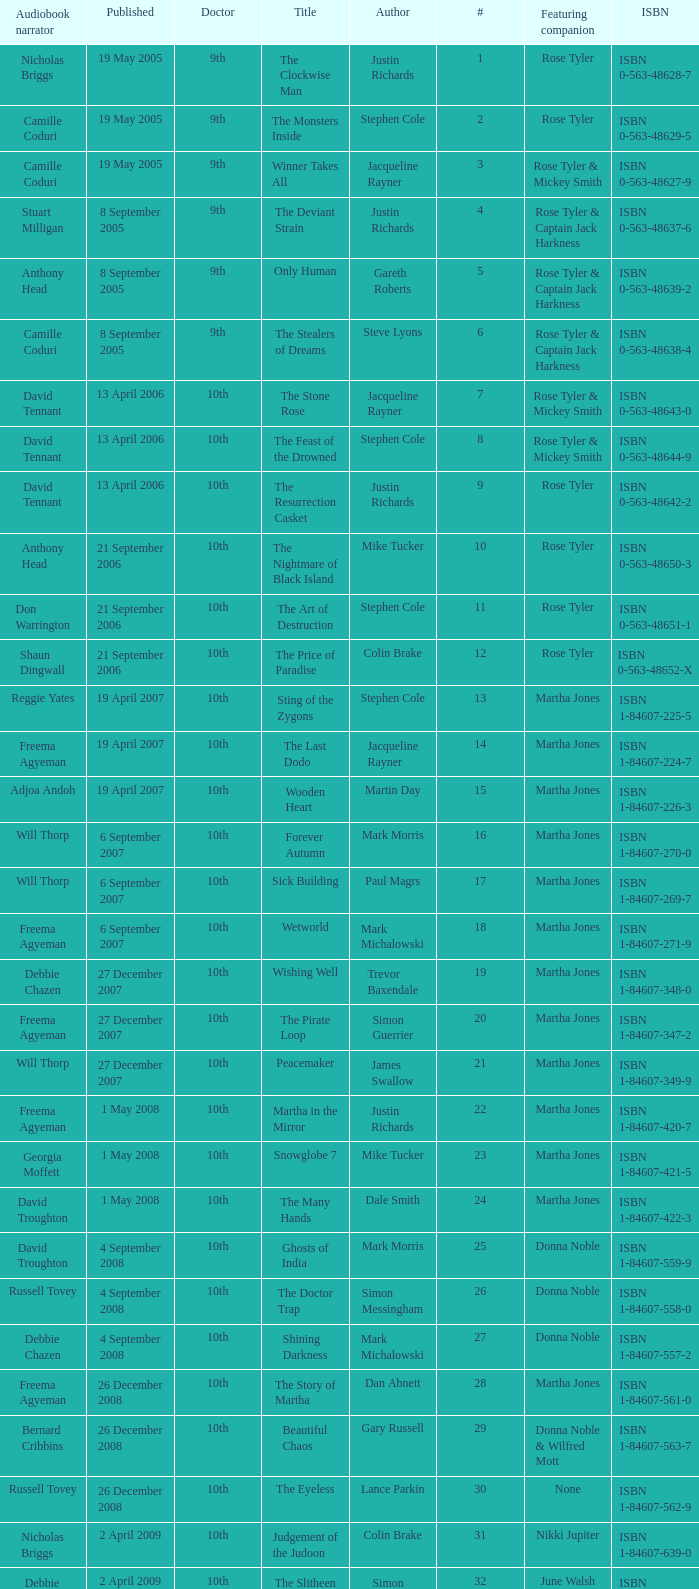What is the title of ISBN 1-84990-243-7? The Silent Stars Go By. 